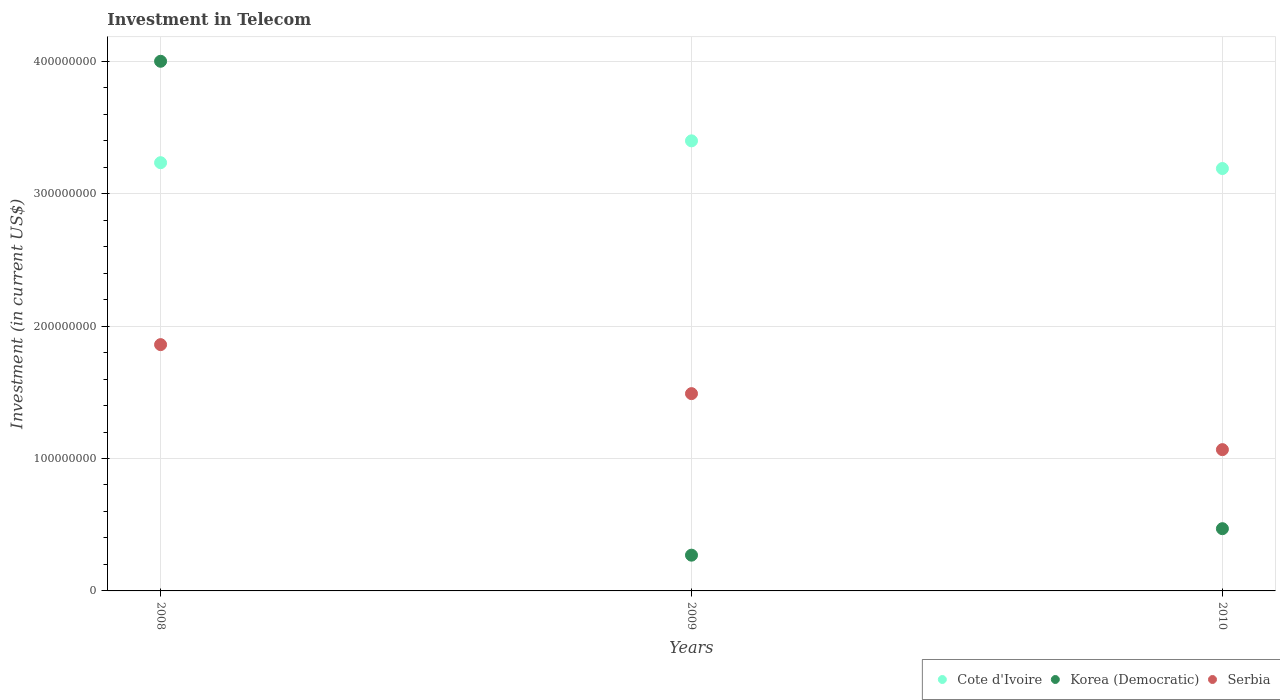Is the number of dotlines equal to the number of legend labels?
Provide a short and direct response. Yes. What is the amount invested in telecom in Korea (Democratic) in 2008?
Give a very brief answer. 4.00e+08. Across all years, what is the maximum amount invested in telecom in Cote d'Ivoire?
Provide a succinct answer. 3.40e+08. Across all years, what is the minimum amount invested in telecom in Serbia?
Keep it short and to the point. 1.07e+08. In which year was the amount invested in telecom in Cote d'Ivoire minimum?
Offer a very short reply. 2010. What is the total amount invested in telecom in Korea (Democratic) in the graph?
Ensure brevity in your answer.  4.74e+08. What is the difference between the amount invested in telecom in Korea (Democratic) in 2008 and that in 2009?
Offer a terse response. 3.73e+08. What is the difference between the amount invested in telecom in Korea (Democratic) in 2010 and the amount invested in telecom in Cote d'Ivoire in 2008?
Provide a succinct answer. -2.76e+08. What is the average amount invested in telecom in Cote d'Ivoire per year?
Provide a short and direct response. 3.27e+08. In the year 2010, what is the difference between the amount invested in telecom in Korea (Democratic) and amount invested in telecom in Serbia?
Your response must be concise. -5.97e+07. In how many years, is the amount invested in telecom in Serbia greater than 40000000 US$?
Keep it short and to the point. 3. What is the ratio of the amount invested in telecom in Cote d'Ivoire in 2008 to that in 2009?
Make the answer very short. 0.95. Is the difference between the amount invested in telecom in Korea (Democratic) in 2009 and 2010 greater than the difference between the amount invested in telecom in Serbia in 2009 and 2010?
Your response must be concise. No. What is the difference between the highest and the second highest amount invested in telecom in Cote d'Ivoire?
Offer a terse response. 1.65e+07. What is the difference between the highest and the lowest amount invested in telecom in Serbia?
Provide a short and direct response. 7.93e+07. Is the sum of the amount invested in telecom in Cote d'Ivoire in 2008 and 2010 greater than the maximum amount invested in telecom in Serbia across all years?
Provide a short and direct response. Yes. Does the amount invested in telecom in Korea (Democratic) monotonically increase over the years?
Your answer should be compact. No. Does the graph contain any zero values?
Your response must be concise. No. How are the legend labels stacked?
Your answer should be compact. Horizontal. What is the title of the graph?
Offer a very short reply. Investment in Telecom. What is the label or title of the X-axis?
Make the answer very short. Years. What is the label or title of the Y-axis?
Make the answer very short. Investment (in current US$). What is the Investment (in current US$) of Cote d'Ivoire in 2008?
Ensure brevity in your answer.  3.23e+08. What is the Investment (in current US$) in Korea (Democratic) in 2008?
Ensure brevity in your answer.  4.00e+08. What is the Investment (in current US$) of Serbia in 2008?
Offer a very short reply. 1.86e+08. What is the Investment (in current US$) in Cote d'Ivoire in 2009?
Offer a terse response. 3.40e+08. What is the Investment (in current US$) of Korea (Democratic) in 2009?
Offer a very short reply. 2.70e+07. What is the Investment (in current US$) in Serbia in 2009?
Keep it short and to the point. 1.49e+08. What is the Investment (in current US$) of Cote d'Ivoire in 2010?
Your answer should be compact. 3.19e+08. What is the Investment (in current US$) of Korea (Democratic) in 2010?
Keep it short and to the point. 4.70e+07. What is the Investment (in current US$) in Serbia in 2010?
Ensure brevity in your answer.  1.07e+08. Across all years, what is the maximum Investment (in current US$) of Cote d'Ivoire?
Make the answer very short. 3.40e+08. Across all years, what is the maximum Investment (in current US$) in Korea (Democratic)?
Make the answer very short. 4.00e+08. Across all years, what is the maximum Investment (in current US$) of Serbia?
Ensure brevity in your answer.  1.86e+08. Across all years, what is the minimum Investment (in current US$) in Cote d'Ivoire?
Your answer should be very brief. 3.19e+08. Across all years, what is the minimum Investment (in current US$) of Korea (Democratic)?
Ensure brevity in your answer.  2.70e+07. Across all years, what is the minimum Investment (in current US$) in Serbia?
Give a very brief answer. 1.07e+08. What is the total Investment (in current US$) of Cote d'Ivoire in the graph?
Ensure brevity in your answer.  9.82e+08. What is the total Investment (in current US$) of Korea (Democratic) in the graph?
Offer a terse response. 4.74e+08. What is the total Investment (in current US$) of Serbia in the graph?
Your answer should be compact. 4.42e+08. What is the difference between the Investment (in current US$) of Cote d'Ivoire in 2008 and that in 2009?
Offer a terse response. -1.65e+07. What is the difference between the Investment (in current US$) of Korea (Democratic) in 2008 and that in 2009?
Provide a short and direct response. 3.73e+08. What is the difference between the Investment (in current US$) of Serbia in 2008 and that in 2009?
Offer a terse response. 3.70e+07. What is the difference between the Investment (in current US$) of Cote d'Ivoire in 2008 and that in 2010?
Your answer should be very brief. 4.40e+06. What is the difference between the Investment (in current US$) in Korea (Democratic) in 2008 and that in 2010?
Provide a short and direct response. 3.53e+08. What is the difference between the Investment (in current US$) of Serbia in 2008 and that in 2010?
Provide a succinct answer. 7.93e+07. What is the difference between the Investment (in current US$) of Cote d'Ivoire in 2009 and that in 2010?
Provide a short and direct response. 2.09e+07. What is the difference between the Investment (in current US$) of Korea (Democratic) in 2009 and that in 2010?
Make the answer very short. -2.00e+07. What is the difference between the Investment (in current US$) in Serbia in 2009 and that in 2010?
Offer a terse response. 4.23e+07. What is the difference between the Investment (in current US$) of Cote d'Ivoire in 2008 and the Investment (in current US$) of Korea (Democratic) in 2009?
Provide a short and direct response. 2.96e+08. What is the difference between the Investment (in current US$) of Cote d'Ivoire in 2008 and the Investment (in current US$) of Serbia in 2009?
Your answer should be compact. 1.74e+08. What is the difference between the Investment (in current US$) in Korea (Democratic) in 2008 and the Investment (in current US$) in Serbia in 2009?
Ensure brevity in your answer.  2.51e+08. What is the difference between the Investment (in current US$) of Cote d'Ivoire in 2008 and the Investment (in current US$) of Korea (Democratic) in 2010?
Give a very brief answer. 2.76e+08. What is the difference between the Investment (in current US$) of Cote d'Ivoire in 2008 and the Investment (in current US$) of Serbia in 2010?
Your response must be concise. 2.17e+08. What is the difference between the Investment (in current US$) in Korea (Democratic) in 2008 and the Investment (in current US$) in Serbia in 2010?
Keep it short and to the point. 2.93e+08. What is the difference between the Investment (in current US$) of Cote d'Ivoire in 2009 and the Investment (in current US$) of Korea (Democratic) in 2010?
Keep it short and to the point. 2.93e+08. What is the difference between the Investment (in current US$) of Cote d'Ivoire in 2009 and the Investment (in current US$) of Serbia in 2010?
Your answer should be very brief. 2.33e+08. What is the difference between the Investment (in current US$) in Korea (Democratic) in 2009 and the Investment (in current US$) in Serbia in 2010?
Provide a short and direct response. -7.97e+07. What is the average Investment (in current US$) in Cote d'Ivoire per year?
Provide a short and direct response. 3.27e+08. What is the average Investment (in current US$) in Korea (Democratic) per year?
Your response must be concise. 1.58e+08. What is the average Investment (in current US$) in Serbia per year?
Offer a very short reply. 1.47e+08. In the year 2008, what is the difference between the Investment (in current US$) in Cote d'Ivoire and Investment (in current US$) in Korea (Democratic)?
Keep it short and to the point. -7.66e+07. In the year 2008, what is the difference between the Investment (in current US$) of Cote d'Ivoire and Investment (in current US$) of Serbia?
Make the answer very short. 1.37e+08. In the year 2008, what is the difference between the Investment (in current US$) of Korea (Democratic) and Investment (in current US$) of Serbia?
Provide a short and direct response. 2.14e+08. In the year 2009, what is the difference between the Investment (in current US$) of Cote d'Ivoire and Investment (in current US$) of Korea (Democratic)?
Provide a short and direct response. 3.13e+08. In the year 2009, what is the difference between the Investment (in current US$) in Cote d'Ivoire and Investment (in current US$) in Serbia?
Provide a short and direct response. 1.91e+08. In the year 2009, what is the difference between the Investment (in current US$) in Korea (Democratic) and Investment (in current US$) in Serbia?
Offer a terse response. -1.22e+08. In the year 2010, what is the difference between the Investment (in current US$) of Cote d'Ivoire and Investment (in current US$) of Korea (Democratic)?
Ensure brevity in your answer.  2.72e+08. In the year 2010, what is the difference between the Investment (in current US$) of Cote d'Ivoire and Investment (in current US$) of Serbia?
Your response must be concise. 2.12e+08. In the year 2010, what is the difference between the Investment (in current US$) in Korea (Democratic) and Investment (in current US$) in Serbia?
Keep it short and to the point. -5.97e+07. What is the ratio of the Investment (in current US$) of Cote d'Ivoire in 2008 to that in 2009?
Your response must be concise. 0.95. What is the ratio of the Investment (in current US$) of Korea (Democratic) in 2008 to that in 2009?
Give a very brief answer. 14.81. What is the ratio of the Investment (in current US$) in Serbia in 2008 to that in 2009?
Provide a short and direct response. 1.25. What is the ratio of the Investment (in current US$) of Cote d'Ivoire in 2008 to that in 2010?
Provide a succinct answer. 1.01. What is the ratio of the Investment (in current US$) of Korea (Democratic) in 2008 to that in 2010?
Your response must be concise. 8.51. What is the ratio of the Investment (in current US$) in Serbia in 2008 to that in 2010?
Your response must be concise. 1.74. What is the ratio of the Investment (in current US$) of Cote d'Ivoire in 2009 to that in 2010?
Make the answer very short. 1.07. What is the ratio of the Investment (in current US$) in Korea (Democratic) in 2009 to that in 2010?
Your answer should be very brief. 0.57. What is the ratio of the Investment (in current US$) in Serbia in 2009 to that in 2010?
Offer a terse response. 1.4. What is the difference between the highest and the second highest Investment (in current US$) of Cote d'Ivoire?
Keep it short and to the point. 1.65e+07. What is the difference between the highest and the second highest Investment (in current US$) of Korea (Democratic)?
Provide a short and direct response. 3.53e+08. What is the difference between the highest and the second highest Investment (in current US$) in Serbia?
Keep it short and to the point. 3.70e+07. What is the difference between the highest and the lowest Investment (in current US$) in Cote d'Ivoire?
Provide a short and direct response. 2.09e+07. What is the difference between the highest and the lowest Investment (in current US$) in Korea (Democratic)?
Provide a succinct answer. 3.73e+08. What is the difference between the highest and the lowest Investment (in current US$) of Serbia?
Offer a very short reply. 7.93e+07. 